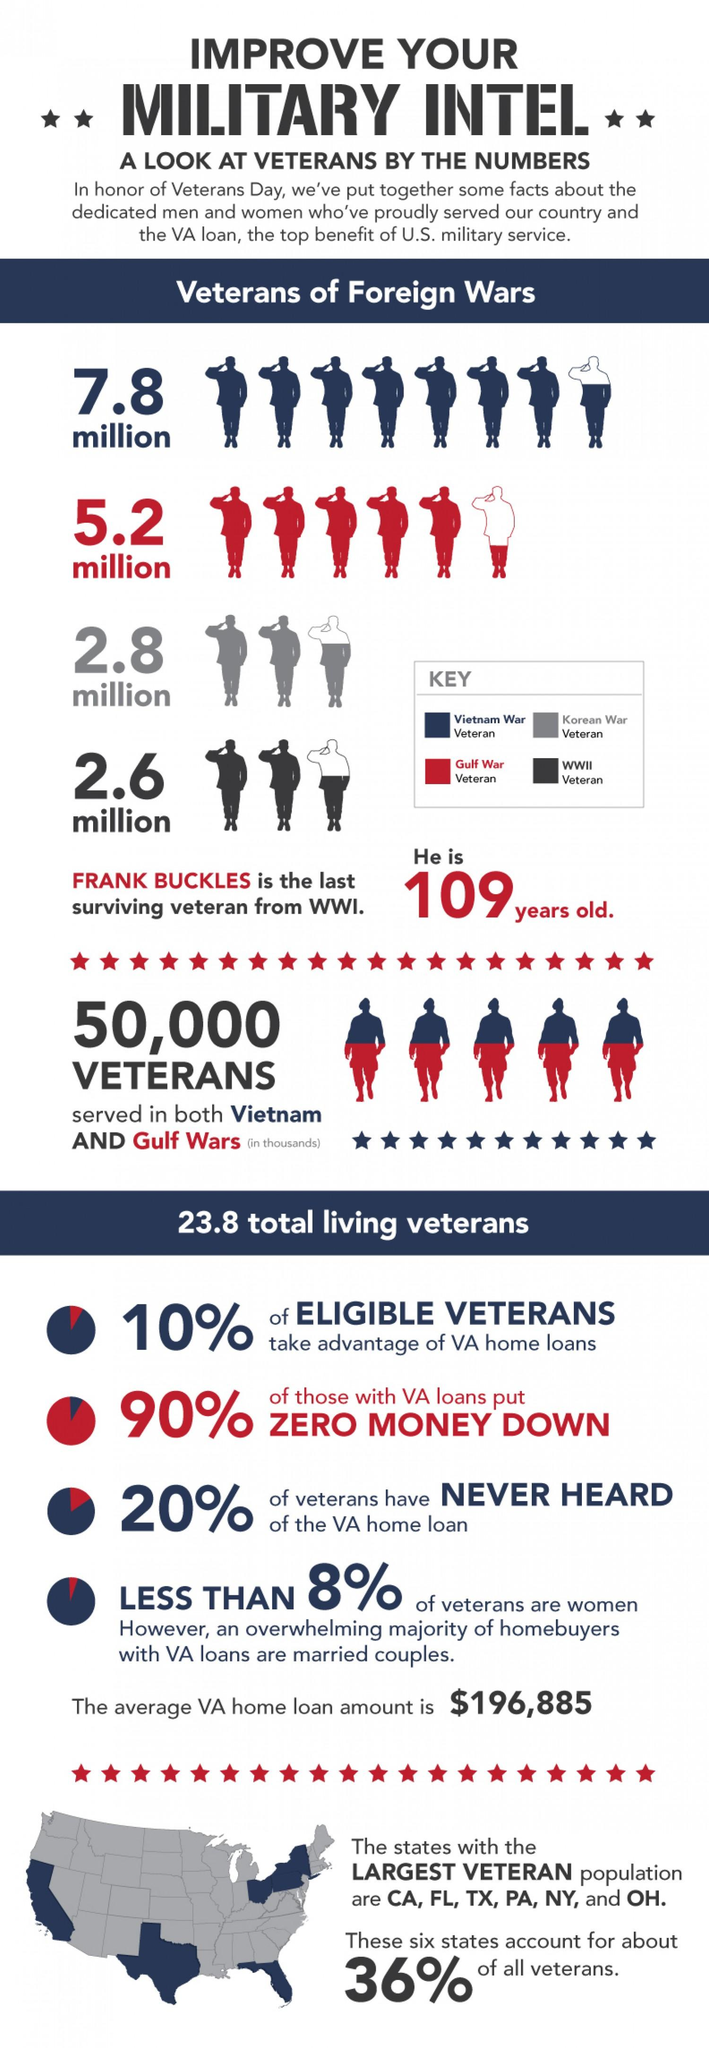Outline some significant characteristics in this image. According to estimates, approximately 7.8 million American veterans served in the Vietnam War. During the Second World War, approximately 2.6 million American veterans served. During the Gulf War, approximately 5.2 million American veterans served. The age of the last living veteran of the First World War is 109 years. 